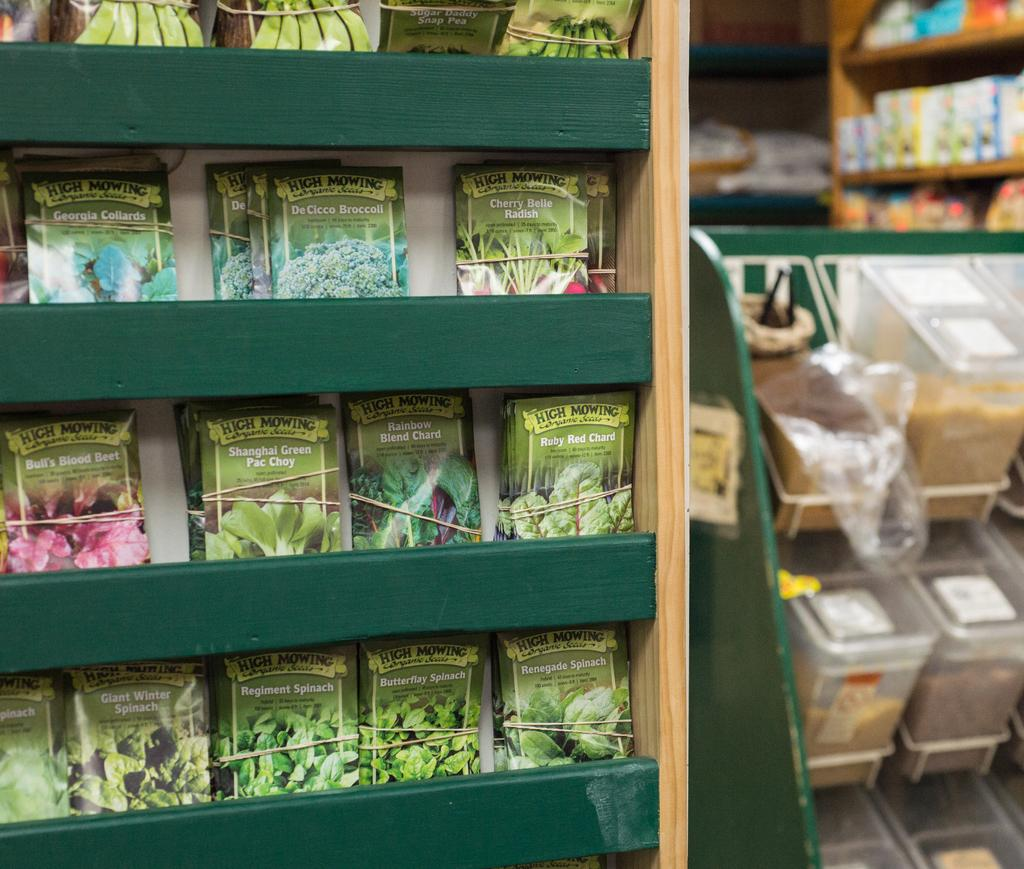<image>
Write a terse but informative summary of the picture. A wooden display in a store has packages of seeds on it including some labeled De Cicco Broccoli. 